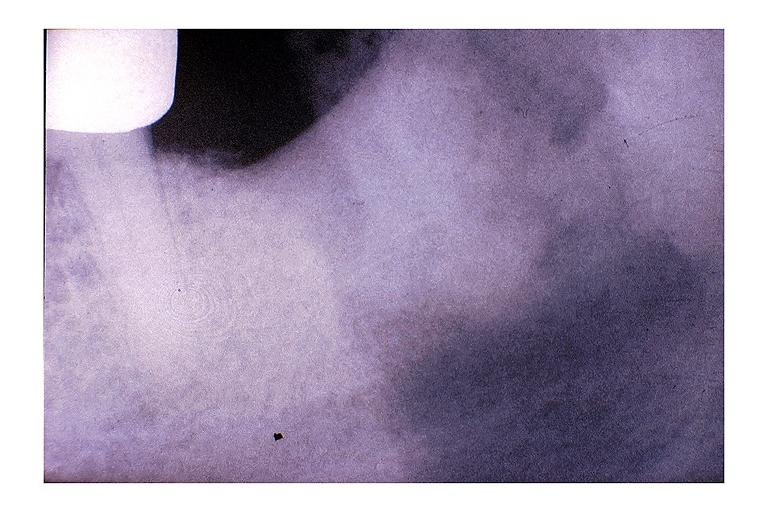does appendix show chronic osteomyelitis?
Answer the question using a single word or phrase. No 